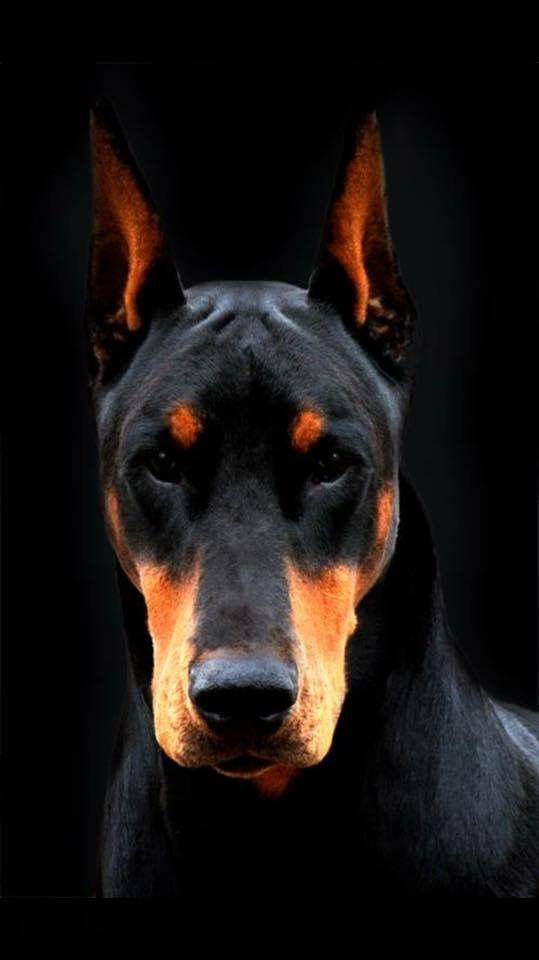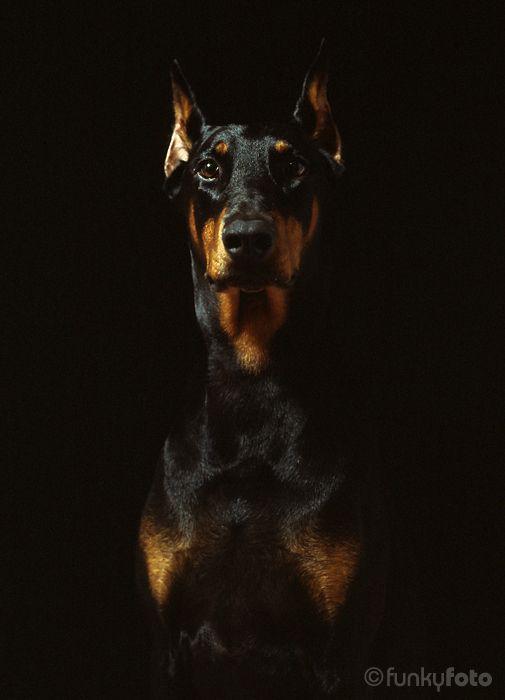The first image is the image on the left, the second image is the image on the right. For the images displayed, is the sentence "The left image contains at least two dogs." factually correct? Answer yes or no. No. The first image is the image on the left, the second image is the image on the right. Considering the images on both sides, is "Each image contains the same number of dogs, at least one of the dogs depicted gazes straight forward, and all dogs are erect-eared doberman." valid? Answer yes or no. Yes. 